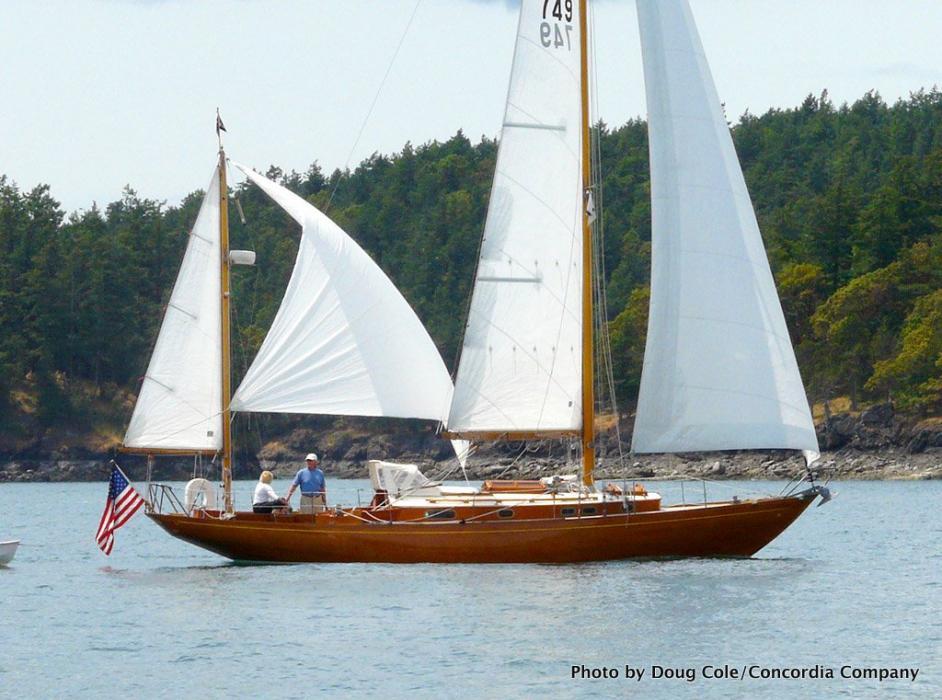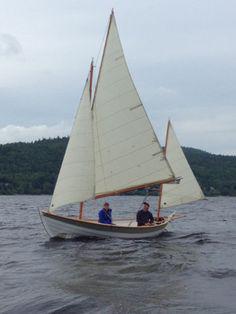The first image is the image on the left, the second image is the image on the right. Analyze the images presented: Is the assertion "The majority of masts are furled on each sailboat." valid? Answer yes or no. No. The first image is the image on the left, the second image is the image on the right. Given the left and right images, does the statement "An image shows a dark-bodied boat with its main sail still furled." hold true? Answer yes or no. No. 